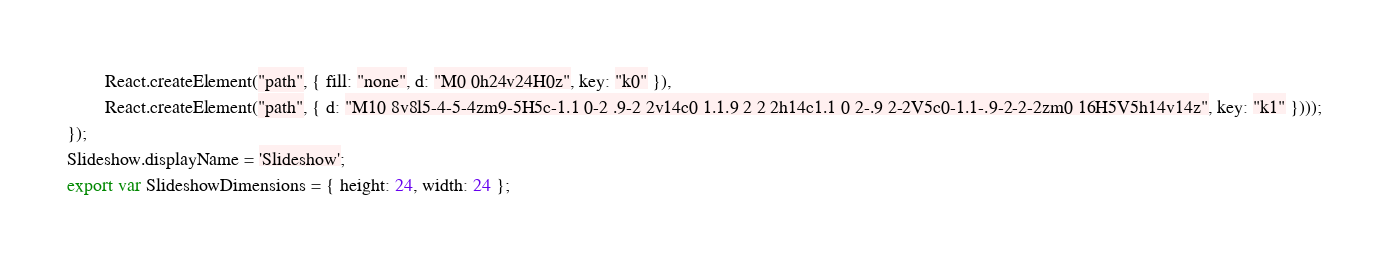<code> <loc_0><loc_0><loc_500><loc_500><_JavaScript_>        React.createElement("path", { fill: "none", d: "M0 0h24v24H0z", key: "k0" }),
        React.createElement("path", { d: "M10 8v8l5-4-5-4zm9-5H5c-1.1 0-2 .9-2 2v14c0 1.1.9 2 2 2h14c1.1 0 2-.9 2-2V5c0-1.1-.9-2-2-2zm0 16H5V5h14v14z", key: "k1" })));
});
Slideshow.displayName = 'Slideshow';
export var SlideshowDimensions = { height: 24, width: 24 };
</code> 